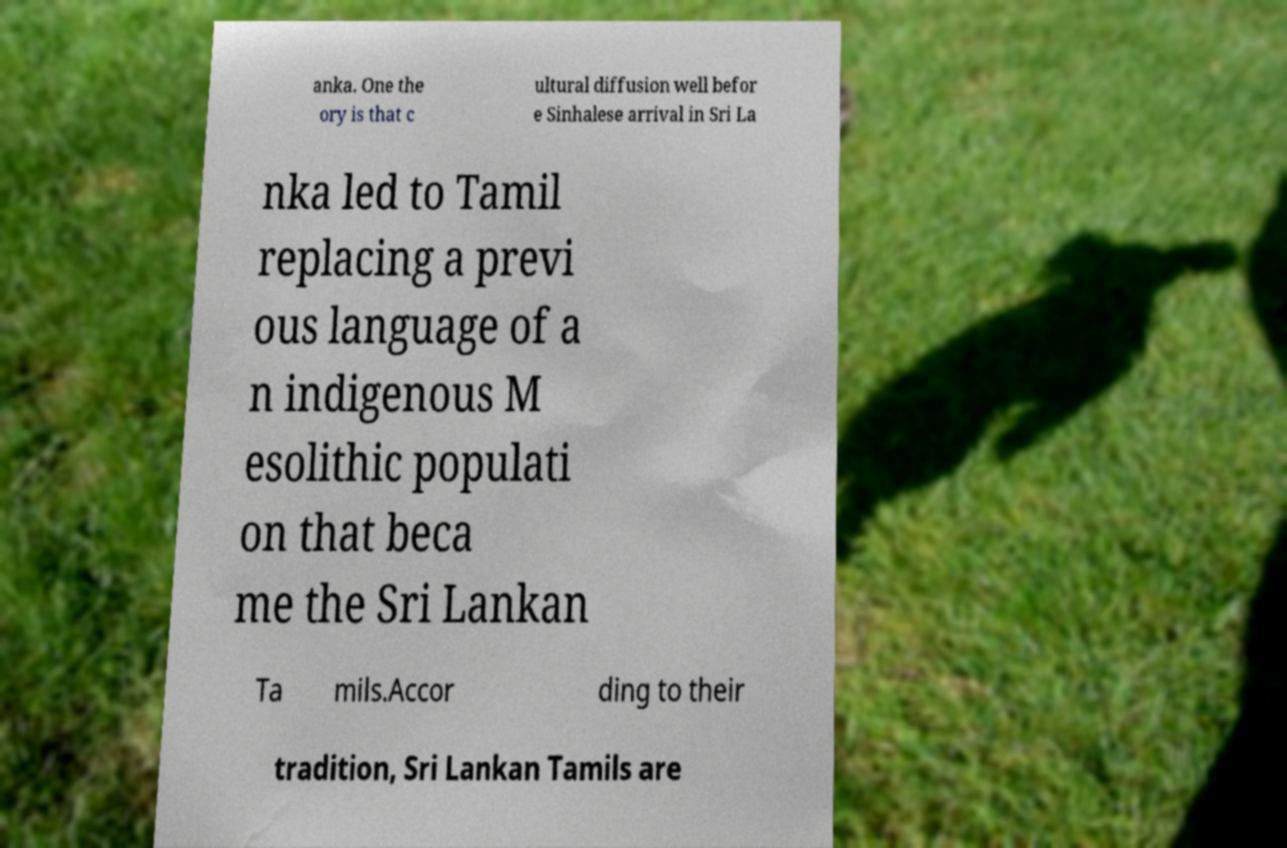Can you read and provide the text displayed in the image?This photo seems to have some interesting text. Can you extract and type it out for me? anka. One the ory is that c ultural diffusion well befor e Sinhalese arrival in Sri La nka led to Tamil replacing a previ ous language of a n indigenous M esolithic populati on that beca me the Sri Lankan Ta mils.Accor ding to their tradition, Sri Lankan Tamils are 